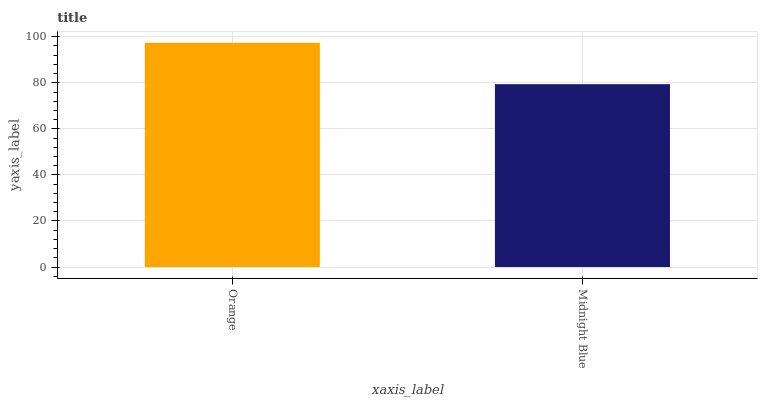Is Midnight Blue the minimum?
Answer yes or no. Yes. Is Orange the maximum?
Answer yes or no. Yes. Is Midnight Blue the maximum?
Answer yes or no. No. Is Orange greater than Midnight Blue?
Answer yes or no. Yes. Is Midnight Blue less than Orange?
Answer yes or no. Yes. Is Midnight Blue greater than Orange?
Answer yes or no. No. Is Orange less than Midnight Blue?
Answer yes or no. No. Is Orange the high median?
Answer yes or no. Yes. Is Midnight Blue the low median?
Answer yes or no. Yes. Is Midnight Blue the high median?
Answer yes or no. No. Is Orange the low median?
Answer yes or no. No. 